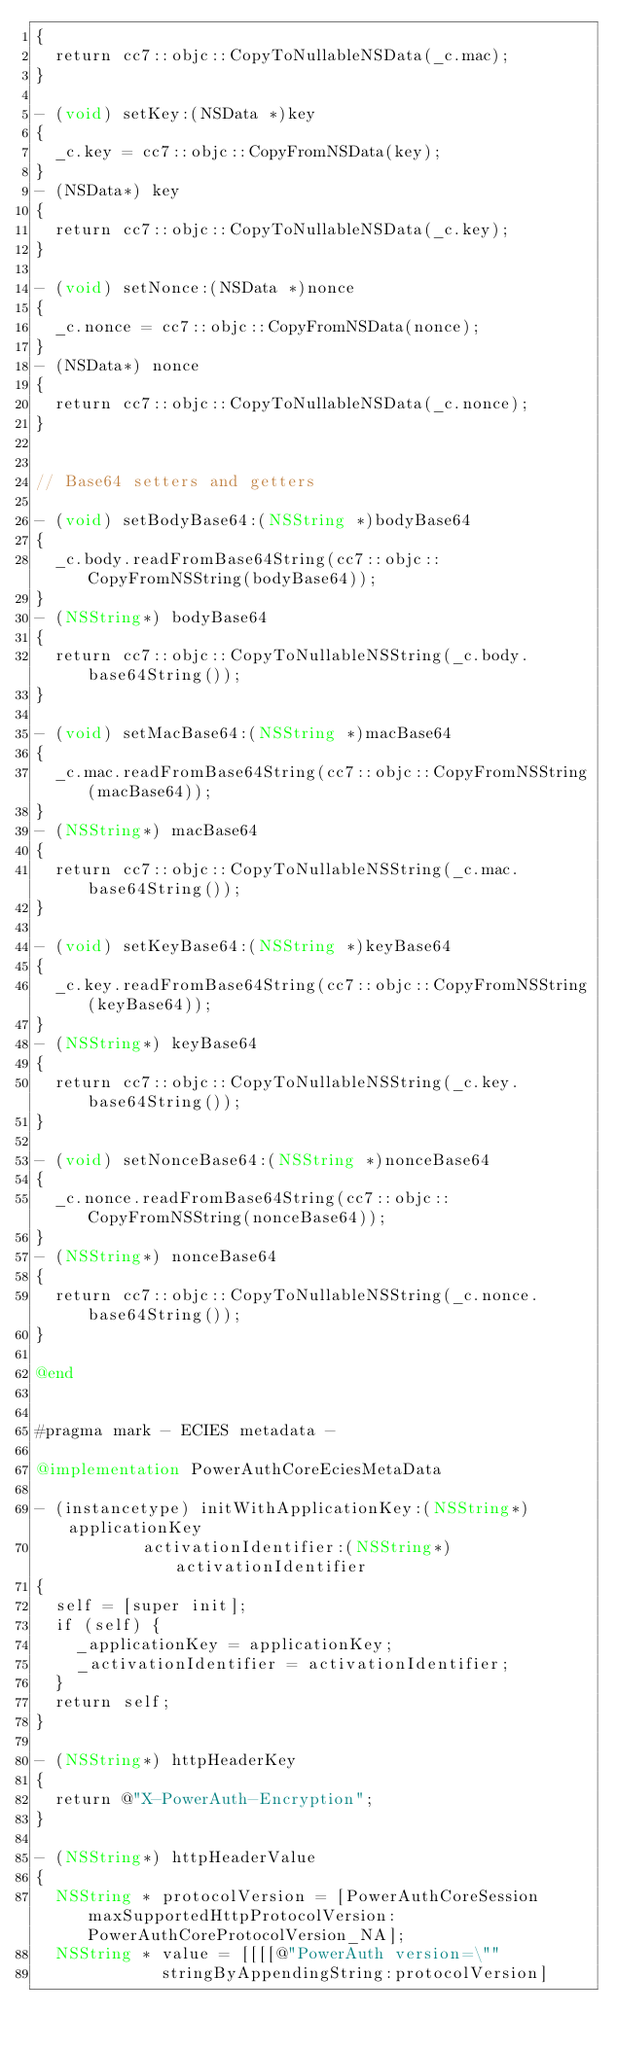Convert code to text. <code><loc_0><loc_0><loc_500><loc_500><_ObjectiveC_>{
	return cc7::objc::CopyToNullableNSData(_c.mac);
}

- (void) setKey:(NSData *)key
{
	_c.key = cc7::objc::CopyFromNSData(key);
}
- (NSData*) key
{
	return cc7::objc::CopyToNullableNSData(_c.key);
}

- (void) setNonce:(NSData *)nonce
{
	_c.nonce = cc7::objc::CopyFromNSData(nonce);
}
- (NSData*) nonce
{
	return cc7::objc::CopyToNullableNSData(_c.nonce);
}


// Base64 setters and getters

- (void) setBodyBase64:(NSString *)bodyBase64
{
	_c.body.readFromBase64String(cc7::objc::CopyFromNSString(bodyBase64));
}
- (NSString*) bodyBase64
{
	return cc7::objc::CopyToNullableNSString(_c.body.base64String());
}

- (void) setMacBase64:(NSString *)macBase64
{
	_c.mac.readFromBase64String(cc7::objc::CopyFromNSString(macBase64));
}
- (NSString*) macBase64
{
	return cc7::objc::CopyToNullableNSString(_c.mac.base64String());
}

- (void) setKeyBase64:(NSString *)keyBase64
{
	_c.key.readFromBase64String(cc7::objc::CopyFromNSString(keyBase64));
}
- (NSString*) keyBase64
{
	return cc7::objc::CopyToNullableNSString(_c.key.base64String());
}

- (void) setNonceBase64:(NSString *)nonceBase64
{
	_c.nonce.readFromBase64String(cc7::objc::CopyFromNSString(nonceBase64));
}
- (NSString*) nonceBase64
{
	return cc7::objc::CopyToNullableNSString(_c.nonce.base64String());
}

@end


#pragma mark - ECIES metadata -

@implementation PowerAuthCoreEciesMetaData

- (instancetype) initWithApplicationKey:(NSString*)applicationKey
				   activationIdentifier:(NSString*)activationIdentifier
{
	self = [super init];
	if (self) {
		_applicationKey = applicationKey;
		_activationIdentifier = activationIdentifier;
	}
	return self;
}

- (NSString*) httpHeaderKey
{
	return @"X-PowerAuth-Encryption";
}

- (NSString*) httpHeaderValue
{
	NSString * protocolVersion = [PowerAuthCoreSession maxSupportedHttpProtocolVersion:PowerAuthCoreProtocolVersion_NA];
	NSString * value = [[[[@"PowerAuth version=\""
						 stringByAppendingString:protocolVersion]</code> 